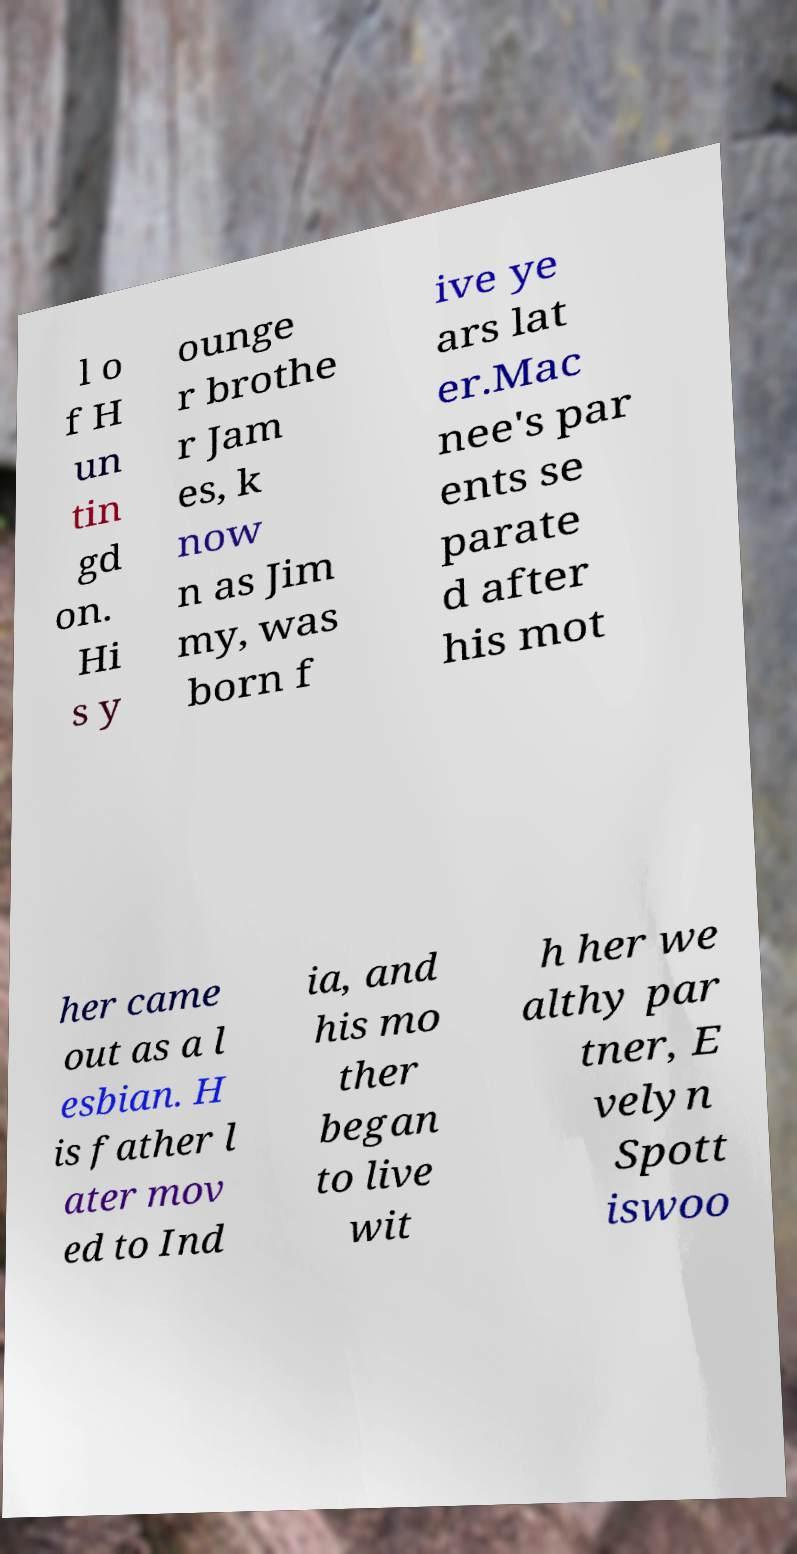Could you extract and type out the text from this image? l o f H un tin gd on. Hi s y ounge r brothe r Jam es, k now n as Jim my, was born f ive ye ars lat er.Mac nee's par ents se parate d after his mot her came out as a l esbian. H is father l ater mov ed to Ind ia, and his mo ther began to live wit h her we althy par tner, E velyn Spott iswoo 